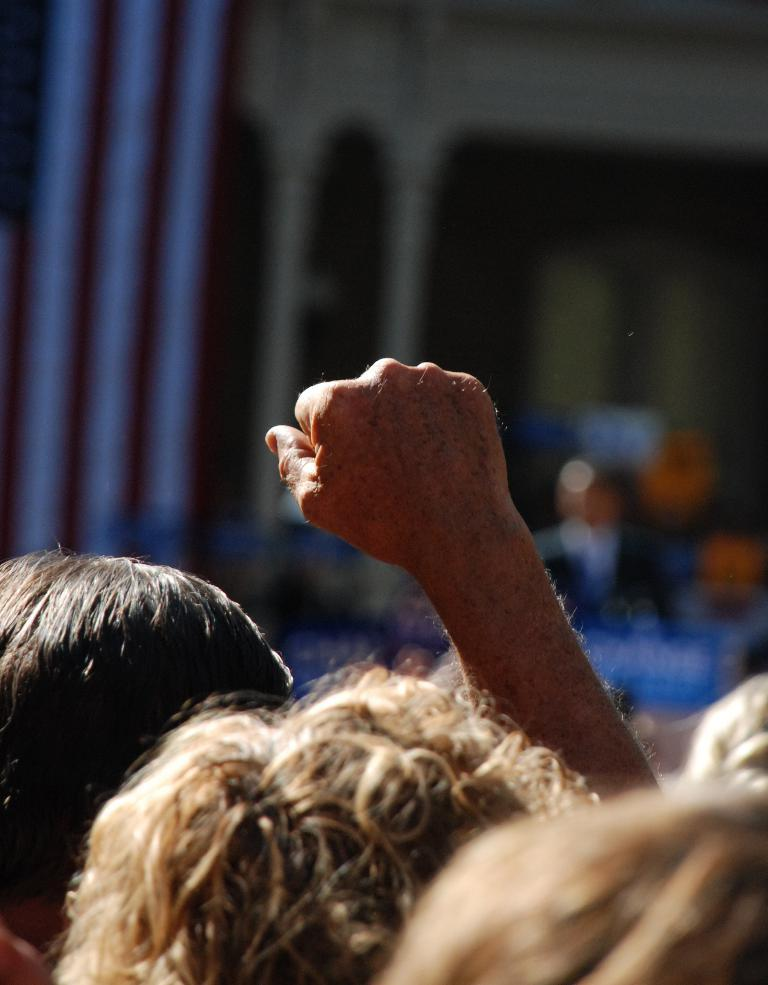What is located at the bottom of the image? There are human heads at the bottom of the image. What body part can be seen in the image? There is a hand visible in the image. How would you describe the background of the image? The background of the image is blurry. What type of can is being exchanged between the human heads in the image? There is no can or exchange of objects depicted in the image; it only features human heads and a hand. 